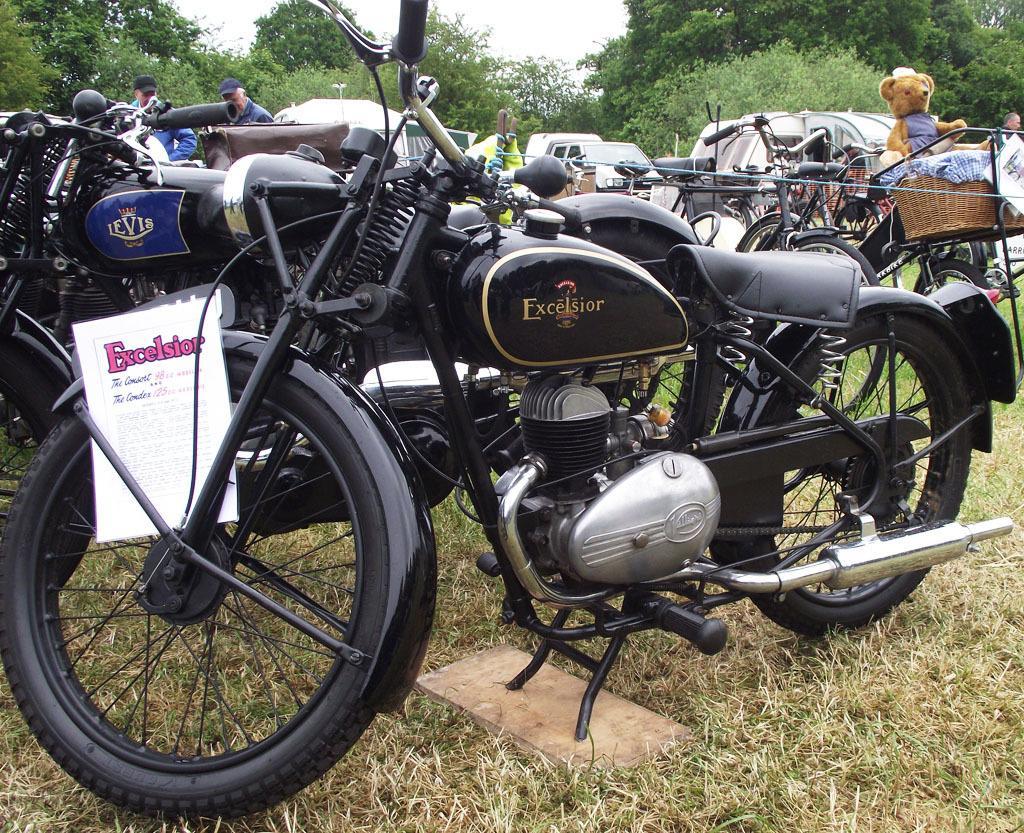Please provide a concise description of this image. On this grass there are motorbikes, bicycles and vehicles. In this basket there is a teddy. Background there are trees. Here we can see two people. A paper is on wheel. 